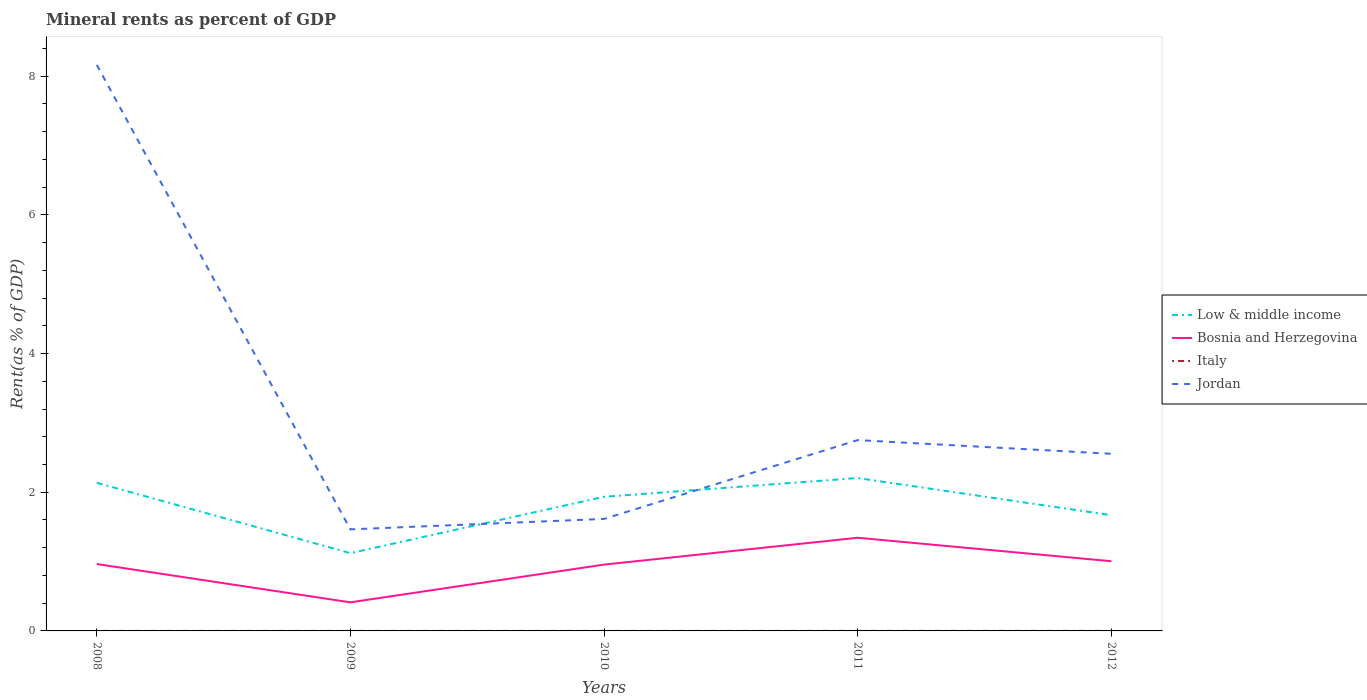How many different coloured lines are there?
Ensure brevity in your answer.  4. Across all years, what is the maximum mineral rent in Bosnia and Herzegovina?
Offer a terse response. 0.41. In which year was the mineral rent in Jordan maximum?
Your answer should be compact. 2009. What is the total mineral rent in Bosnia and Herzegovina in the graph?
Offer a terse response. -0.59. What is the difference between the highest and the second highest mineral rent in Italy?
Your answer should be compact. 0. What is the difference between the highest and the lowest mineral rent in Jordan?
Ensure brevity in your answer.  1. Is the mineral rent in Jordan strictly greater than the mineral rent in Bosnia and Herzegovina over the years?
Your answer should be very brief. No. How many lines are there?
Provide a succinct answer. 4. What is the difference between two consecutive major ticks on the Y-axis?
Offer a terse response. 2. Does the graph contain any zero values?
Provide a succinct answer. No. Does the graph contain grids?
Make the answer very short. No. How many legend labels are there?
Offer a very short reply. 4. What is the title of the graph?
Your answer should be compact. Mineral rents as percent of GDP. What is the label or title of the X-axis?
Your answer should be compact. Years. What is the label or title of the Y-axis?
Your answer should be very brief. Rent(as % of GDP). What is the Rent(as % of GDP) of Low & middle income in 2008?
Give a very brief answer. 2.14. What is the Rent(as % of GDP) in Bosnia and Herzegovina in 2008?
Your answer should be very brief. 0.96. What is the Rent(as % of GDP) in Italy in 2008?
Provide a succinct answer. 0. What is the Rent(as % of GDP) in Jordan in 2008?
Make the answer very short. 8.16. What is the Rent(as % of GDP) in Low & middle income in 2009?
Offer a terse response. 1.12. What is the Rent(as % of GDP) in Bosnia and Herzegovina in 2009?
Provide a short and direct response. 0.41. What is the Rent(as % of GDP) of Italy in 2009?
Provide a succinct answer. 0. What is the Rent(as % of GDP) of Jordan in 2009?
Your response must be concise. 1.46. What is the Rent(as % of GDP) in Low & middle income in 2010?
Provide a short and direct response. 1.93. What is the Rent(as % of GDP) in Bosnia and Herzegovina in 2010?
Provide a short and direct response. 0.96. What is the Rent(as % of GDP) in Italy in 2010?
Make the answer very short. 0. What is the Rent(as % of GDP) in Jordan in 2010?
Your response must be concise. 1.62. What is the Rent(as % of GDP) of Low & middle income in 2011?
Provide a short and direct response. 2.21. What is the Rent(as % of GDP) of Bosnia and Herzegovina in 2011?
Provide a short and direct response. 1.34. What is the Rent(as % of GDP) in Italy in 2011?
Your answer should be compact. 0. What is the Rent(as % of GDP) of Jordan in 2011?
Provide a succinct answer. 2.75. What is the Rent(as % of GDP) in Low & middle income in 2012?
Your response must be concise. 1.67. What is the Rent(as % of GDP) in Bosnia and Herzegovina in 2012?
Your response must be concise. 1.01. What is the Rent(as % of GDP) in Italy in 2012?
Make the answer very short. 0. What is the Rent(as % of GDP) in Jordan in 2012?
Offer a very short reply. 2.55. Across all years, what is the maximum Rent(as % of GDP) of Low & middle income?
Your answer should be very brief. 2.21. Across all years, what is the maximum Rent(as % of GDP) of Bosnia and Herzegovina?
Offer a very short reply. 1.34. Across all years, what is the maximum Rent(as % of GDP) in Italy?
Provide a succinct answer. 0. Across all years, what is the maximum Rent(as % of GDP) in Jordan?
Your answer should be very brief. 8.16. Across all years, what is the minimum Rent(as % of GDP) of Low & middle income?
Keep it short and to the point. 1.12. Across all years, what is the minimum Rent(as % of GDP) of Bosnia and Herzegovina?
Your response must be concise. 0.41. Across all years, what is the minimum Rent(as % of GDP) in Italy?
Your answer should be compact. 0. Across all years, what is the minimum Rent(as % of GDP) of Jordan?
Keep it short and to the point. 1.46. What is the total Rent(as % of GDP) of Low & middle income in the graph?
Provide a short and direct response. 9.07. What is the total Rent(as % of GDP) in Bosnia and Herzegovina in the graph?
Make the answer very short. 4.68. What is the total Rent(as % of GDP) of Italy in the graph?
Provide a short and direct response. 0. What is the total Rent(as % of GDP) in Jordan in the graph?
Your response must be concise. 16.55. What is the difference between the Rent(as % of GDP) of Low & middle income in 2008 and that in 2009?
Offer a very short reply. 1.02. What is the difference between the Rent(as % of GDP) in Bosnia and Herzegovina in 2008 and that in 2009?
Ensure brevity in your answer.  0.55. What is the difference between the Rent(as % of GDP) of Italy in 2008 and that in 2009?
Give a very brief answer. -0. What is the difference between the Rent(as % of GDP) in Jordan in 2008 and that in 2009?
Offer a terse response. 6.7. What is the difference between the Rent(as % of GDP) in Low & middle income in 2008 and that in 2010?
Offer a very short reply. 0.2. What is the difference between the Rent(as % of GDP) in Bosnia and Herzegovina in 2008 and that in 2010?
Give a very brief answer. 0.01. What is the difference between the Rent(as % of GDP) in Italy in 2008 and that in 2010?
Ensure brevity in your answer.  -0. What is the difference between the Rent(as % of GDP) of Jordan in 2008 and that in 2010?
Provide a succinct answer. 6.55. What is the difference between the Rent(as % of GDP) in Low & middle income in 2008 and that in 2011?
Make the answer very short. -0.07. What is the difference between the Rent(as % of GDP) of Bosnia and Herzegovina in 2008 and that in 2011?
Make the answer very short. -0.38. What is the difference between the Rent(as % of GDP) in Italy in 2008 and that in 2011?
Give a very brief answer. -0. What is the difference between the Rent(as % of GDP) of Jordan in 2008 and that in 2011?
Offer a terse response. 5.41. What is the difference between the Rent(as % of GDP) of Low & middle income in 2008 and that in 2012?
Offer a very short reply. 0.47. What is the difference between the Rent(as % of GDP) in Bosnia and Herzegovina in 2008 and that in 2012?
Ensure brevity in your answer.  -0.04. What is the difference between the Rent(as % of GDP) in Italy in 2008 and that in 2012?
Offer a terse response. -0. What is the difference between the Rent(as % of GDP) of Jordan in 2008 and that in 2012?
Your answer should be compact. 5.61. What is the difference between the Rent(as % of GDP) of Low & middle income in 2009 and that in 2010?
Ensure brevity in your answer.  -0.81. What is the difference between the Rent(as % of GDP) in Bosnia and Herzegovina in 2009 and that in 2010?
Ensure brevity in your answer.  -0.54. What is the difference between the Rent(as % of GDP) in Italy in 2009 and that in 2010?
Give a very brief answer. -0. What is the difference between the Rent(as % of GDP) of Jordan in 2009 and that in 2010?
Your answer should be compact. -0.15. What is the difference between the Rent(as % of GDP) in Low & middle income in 2009 and that in 2011?
Ensure brevity in your answer.  -1.08. What is the difference between the Rent(as % of GDP) of Bosnia and Herzegovina in 2009 and that in 2011?
Give a very brief answer. -0.93. What is the difference between the Rent(as % of GDP) in Italy in 2009 and that in 2011?
Offer a very short reply. -0. What is the difference between the Rent(as % of GDP) in Jordan in 2009 and that in 2011?
Offer a very short reply. -1.29. What is the difference between the Rent(as % of GDP) in Low & middle income in 2009 and that in 2012?
Ensure brevity in your answer.  -0.55. What is the difference between the Rent(as % of GDP) of Bosnia and Herzegovina in 2009 and that in 2012?
Provide a succinct answer. -0.59. What is the difference between the Rent(as % of GDP) in Italy in 2009 and that in 2012?
Provide a short and direct response. -0. What is the difference between the Rent(as % of GDP) of Jordan in 2009 and that in 2012?
Keep it short and to the point. -1.09. What is the difference between the Rent(as % of GDP) of Low & middle income in 2010 and that in 2011?
Your response must be concise. -0.27. What is the difference between the Rent(as % of GDP) in Bosnia and Herzegovina in 2010 and that in 2011?
Offer a terse response. -0.39. What is the difference between the Rent(as % of GDP) of Italy in 2010 and that in 2011?
Provide a short and direct response. -0. What is the difference between the Rent(as % of GDP) in Jordan in 2010 and that in 2011?
Your response must be concise. -1.14. What is the difference between the Rent(as % of GDP) in Low & middle income in 2010 and that in 2012?
Make the answer very short. 0.27. What is the difference between the Rent(as % of GDP) in Bosnia and Herzegovina in 2010 and that in 2012?
Make the answer very short. -0.05. What is the difference between the Rent(as % of GDP) in Italy in 2010 and that in 2012?
Give a very brief answer. -0. What is the difference between the Rent(as % of GDP) of Jordan in 2010 and that in 2012?
Provide a succinct answer. -0.94. What is the difference between the Rent(as % of GDP) in Low & middle income in 2011 and that in 2012?
Keep it short and to the point. 0.54. What is the difference between the Rent(as % of GDP) in Bosnia and Herzegovina in 2011 and that in 2012?
Offer a terse response. 0.34. What is the difference between the Rent(as % of GDP) of Italy in 2011 and that in 2012?
Provide a short and direct response. -0. What is the difference between the Rent(as % of GDP) in Jordan in 2011 and that in 2012?
Your response must be concise. 0.2. What is the difference between the Rent(as % of GDP) of Low & middle income in 2008 and the Rent(as % of GDP) of Bosnia and Herzegovina in 2009?
Your response must be concise. 1.72. What is the difference between the Rent(as % of GDP) of Low & middle income in 2008 and the Rent(as % of GDP) of Italy in 2009?
Ensure brevity in your answer.  2.14. What is the difference between the Rent(as % of GDP) in Low & middle income in 2008 and the Rent(as % of GDP) in Jordan in 2009?
Your answer should be very brief. 0.67. What is the difference between the Rent(as % of GDP) of Bosnia and Herzegovina in 2008 and the Rent(as % of GDP) of Italy in 2009?
Keep it short and to the point. 0.96. What is the difference between the Rent(as % of GDP) in Italy in 2008 and the Rent(as % of GDP) in Jordan in 2009?
Give a very brief answer. -1.46. What is the difference between the Rent(as % of GDP) in Low & middle income in 2008 and the Rent(as % of GDP) in Bosnia and Herzegovina in 2010?
Your response must be concise. 1.18. What is the difference between the Rent(as % of GDP) in Low & middle income in 2008 and the Rent(as % of GDP) in Italy in 2010?
Offer a very short reply. 2.14. What is the difference between the Rent(as % of GDP) of Low & middle income in 2008 and the Rent(as % of GDP) of Jordan in 2010?
Provide a short and direct response. 0.52. What is the difference between the Rent(as % of GDP) in Bosnia and Herzegovina in 2008 and the Rent(as % of GDP) in Italy in 2010?
Ensure brevity in your answer.  0.96. What is the difference between the Rent(as % of GDP) of Bosnia and Herzegovina in 2008 and the Rent(as % of GDP) of Jordan in 2010?
Make the answer very short. -0.65. What is the difference between the Rent(as % of GDP) in Italy in 2008 and the Rent(as % of GDP) in Jordan in 2010?
Your answer should be very brief. -1.62. What is the difference between the Rent(as % of GDP) of Low & middle income in 2008 and the Rent(as % of GDP) of Bosnia and Herzegovina in 2011?
Give a very brief answer. 0.79. What is the difference between the Rent(as % of GDP) of Low & middle income in 2008 and the Rent(as % of GDP) of Italy in 2011?
Provide a succinct answer. 2.14. What is the difference between the Rent(as % of GDP) of Low & middle income in 2008 and the Rent(as % of GDP) of Jordan in 2011?
Offer a very short reply. -0.62. What is the difference between the Rent(as % of GDP) of Bosnia and Herzegovina in 2008 and the Rent(as % of GDP) of Italy in 2011?
Your answer should be compact. 0.96. What is the difference between the Rent(as % of GDP) of Bosnia and Herzegovina in 2008 and the Rent(as % of GDP) of Jordan in 2011?
Your answer should be very brief. -1.79. What is the difference between the Rent(as % of GDP) in Italy in 2008 and the Rent(as % of GDP) in Jordan in 2011?
Make the answer very short. -2.75. What is the difference between the Rent(as % of GDP) of Low & middle income in 2008 and the Rent(as % of GDP) of Bosnia and Herzegovina in 2012?
Provide a succinct answer. 1.13. What is the difference between the Rent(as % of GDP) in Low & middle income in 2008 and the Rent(as % of GDP) in Italy in 2012?
Your answer should be compact. 2.14. What is the difference between the Rent(as % of GDP) of Low & middle income in 2008 and the Rent(as % of GDP) of Jordan in 2012?
Your response must be concise. -0.42. What is the difference between the Rent(as % of GDP) of Bosnia and Herzegovina in 2008 and the Rent(as % of GDP) of Italy in 2012?
Keep it short and to the point. 0.96. What is the difference between the Rent(as % of GDP) in Bosnia and Herzegovina in 2008 and the Rent(as % of GDP) in Jordan in 2012?
Offer a very short reply. -1.59. What is the difference between the Rent(as % of GDP) in Italy in 2008 and the Rent(as % of GDP) in Jordan in 2012?
Offer a very short reply. -2.55. What is the difference between the Rent(as % of GDP) in Low & middle income in 2009 and the Rent(as % of GDP) in Bosnia and Herzegovina in 2010?
Provide a succinct answer. 0.17. What is the difference between the Rent(as % of GDP) of Low & middle income in 2009 and the Rent(as % of GDP) of Italy in 2010?
Give a very brief answer. 1.12. What is the difference between the Rent(as % of GDP) in Low & middle income in 2009 and the Rent(as % of GDP) in Jordan in 2010?
Provide a succinct answer. -0.49. What is the difference between the Rent(as % of GDP) of Bosnia and Herzegovina in 2009 and the Rent(as % of GDP) of Italy in 2010?
Your answer should be very brief. 0.41. What is the difference between the Rent(as % of GDP) in Bosnia and Herzegovina in 2009 and the Rent(as % of GDP) in Jordan in 2010?
Provide a short and direct response. -1.2. What is the difference between the Rent(as % of GDP) of Italy in 2009 and the Rent(as % of GDP) of Jordan in 2010?
Offer a terse response. -1.62. What is the difference between the Rent(as % of GDP) of Low & middle income in 2009 and the Rent(as % of GDP) of Bosnia and Herzegovina in 2011?
Keep it short and to the point. -0.22. What is the difference between the Rent(as % of GDP) of Low & middle income in 2009 and the Rent(as % of GDP) of Italy in 2011?
Ensure brevity in your answer.  1.12. What is the difference between the Rent(as % of GDP) of Low & middle income in 2009 and the Rent(as % of GDP) of Jordan in 2011?
Ensure brevity in your answer.  -1.63. What is the difference between the Rent(as % of GDP) in Bosnia and Herzegovina in 2009 and the Rent(as % of GDP) in Italy in 2011?
Your response must be concise. 0.41. What is the difference between the Rent(as % of GDP) of Bosnia and Herzegovina in 2009 and the Rent(as % of GDP) of Jordan in 2011?
Your answer should be very brief. -2.34. What is the difference between the Rent(as % of GDP) in Italy in 2009 and the Rent(as % of GDP) in Jordan in 2011?
Make the answer very short. -2.75. What is the difference between the Rent(as % of GDP) of Low & middle income in 2009 and the Rent(as % of GDP) of Bosnia and Herzegovina in 2012?
Give a very brief answer. 0.12. What is the difference between the Rent(as % of GDP) in Low & middle income in 2009 and the Rent(as % of GDP) in Italy in 2012?
Keep it short and to the point. 1.12. What is the difference between the Rent(as % of GDP) in Low & middle income in 2009 and the Rent(as % of GDP) in Jordan in 2012?
Make the answer very short. -1.43. What is the difference between the Rent(as % of GDP) in Bosnia and Herzegovina in 2009 and the Rent(as % of GDP) in Italy in 2012?
Keep it short and to the point. 0.41. What is the difference between the Rent(as % of GDP) in Bosnia and Herzegovina in 2009 and the Rent(as % of GDP) in Jordan in 2012?
Ensure brevity in your answer.  -2.14. What is the difference between the Rent(as % of GDP) in Italy in 2009 and the Rent(as % of GDP) in Jordan in 2012?
Provide a short and direct response. -2.55. What is the difference between the Rent(as % of GDP) of Low & middle income in 2010 and the Rent(as % of GDP) of Bosnia and Herzegovina in 2011?
Offer a terse response. 0.59. What is the difference between the Rent(as % of GDP) of Low & middle income in 2010 and the Rent(as % of GDP) of Italy in 2011?
Your answer should be compact. 1.93. What is the difference between the Rent(as % of GDP) in Low & middle income in 2010 and the Rent(as % of GDP) in Jordan in 2011?
Offer a very short reply. -0.82. What is the difference between the Rent(as % of GDP) in Bosnia and Herzegovina in 2010 and the Rent(as % of GDP) in Italy in 2011?
Your response must be concise. 0.96. What is the difference between the Rent(as % of GDP) of Bosnia and Herzegovina in 2010 and the Rent(as % of GDP) of Jordan in 2011?
Give a very brief answer. -1.8. What is the difference between the Rent(as % of GDP) in Italy in 2010 and the Rent(as % of GDP) in Jordan in 2011?
Provide a short and direct response. -2.75. What is the difference between the Rent(as % of GDP) in Low & middle income in 2010 and the Rent(as % of GDP) in Bosnia and Herzegovina in 2012?
Keep it short and to the point. 0.93. What is the difference between the Rent(as % of GDP) in Low & middle income in 2010 and the Rent(as % of GDP) in Italy in 2012?
Your answer should be very brief. 1.93. What is the difference between the Rent(as % of GDP) of Low & middle income in 2010 and the Rent(as % of GDP) of Jordan in 2012?
Keep it short and to the point. -0.62. What is the difference between the Rent(as % of GDP) in Bosnia and Herzegovina in 2010 and the Rent(as % of GDP) in Italy in 2012?
Your answer should be compact. 0.96. What is the difference between the Rent(as % of GDP) in Bosnia and Herzegovina in 2010 and the Rent(as % of GDP) in Jordan in 2012?
Give a very brief answer. -1.6. What is the difference between the Rent(as % of GDP) of Italy in 2010 and the Rent(as % of GDP) of Jordan in 2012?
Keep it short and to the point. -2.55. What is the difference between the Rent(as % of GDP) in Low & middle income in 2011 and the Rent(as % of GDP) in Bosnia and Herzegovina in 2012?
Make the answer very short. 1.2. What is the difference between the Rent(as % of GDP) of Low & middle income in 2011 and the Rent(as % of GDP) of Italy in 2012?
Provide a short and direct response. 2.2. What is the difference between the Rent(as % of GDP) in Low & middle income in 2011 and the Rent(as % of GDP) in Jordan in 2012?
Provide a short and direct response. -0.35. What is the difference between the Rent(as % of GDP) of Bosnia and Herzegovina in 2011 and the Rent(as % of GDP) of Italy in 2012?
Offer a terse response. 1.34. What is the difference between the Rent(as % of GDP) in Bosnia and Herzegovina in 2011 and the Rent(as % of GDP) in Jordan in 2012?
Your response must be concise. -1.21. What is the difference between the Rent(as % of GDP) of Italy in 2011 and the Rent(as % of GDP) of Jordan in 2012?
Give a very brief answer. -2.55. What is the average Rent(as % of GDP) of Low & middle income per year?
Give a very brief answer. 1.81. What is the average Rent(as % of GDP) of Bosnia and Herzegovina per year?
Ensure brevity in your answer.  0.94. What is the average Rent(as % of GDP) in Italy per year?
Offer a terse response. 0. What is the average Rent(as % of GDP) of Jordan per year?
Offer a terse response. 3.31. In the year 2008, what is the difference between the Rent(as % of GDP) of Low & middle income and Rent(as % of GDP) of Bosnia and Herzegovina?
Offer a very short reply. 1.17. In the year 2008, what is the difference between the Rent(as % of GDP) of Low & middle income and Rent(as % of GDP) of Italy?
Your answer should be compact. 2.14. In the year 2008, what is the difference between the Rent(as % of GDP) of Low & middle income and Rent(as % of GDP) of Jordan?
Ensure brevity in your answer.  -6.03. In the year 2008, what is the difference between the Rent(as % of GDP) in Bosnia and Herzegovina and Rent(as % of GDP) in Italy?
Provide a succinct answer. 0.96. In the year 2008, what is the difference between the Rent(as % of GDP) of Bosnia and Herzegovina and Rent(as % of GDP) of Jordan?
Make the answer very short. -7.2. In the year 2008, what is the difference between the Rent(as % of GDP) in Italy and Rent(as % of GDP) in Jordan?
Your answer should be very brief. -8.16. In the year 2009, what is the difference between the Rent(as % of GDP) in Low & middle income and Rent(as % of GDP) in Bosnia and Herzegovina?
Your response must be concise. 0.71. In the year 2009, what is the difference between the Rent(as % of GDP) of Low & middle income and Rent(as % of GDP) of Italy?
Ensure brevity in your answer.  1.12. In the year 2009, what is the difference between the Rent(as % of GDP) of Low & middle income and Rent(as % of GDP) of Jordan?
Offer a terse response. -0.34. In the year 2009, what is the difference between the Rent(as % of GDP) in Bosnia and Herzegovina and Rent(as % of GDP) in Italy?
Make the answer very short. 0.41. In the year 2009, what is the difference between the Rent(as % of GDP) in Bosnia and Herzegovina and Rent(as % of GDP) in Jordan?
Your answer should be compact. -1.05. In the year 2009, what is the difference between the Rent(as % of GDP) of Italy and Rent(as % of GDP) of Jordan?
Your answer should be very brief. -1.46. In the year 2010, what is the difference between the Rent(as % of GDP) of Low & middle income and Rent(as % of GDP) of Bosnia and Herzegovina?
Keep it short and to the point. 0.98. In the year 2010, what is the difference between the Rent(as % of GDP) in Low & middle income and Rent(as % of GDP) in Italy?
Keep it short and to the point. 1.93. In the year 2010, what is the difference between the Rent(as % of GDP) in Low & middle income and Rent(as % of GDP) in Jordan?
Offer a very short reply. 0.32. In the year 2010, what is the difference between the Rent(as % of GDP) of Bosnia and Herzegovina and Rent(as % of GDP) of Italy?
Ensure brevity in your answer.  0.96. In the year 2010, what is the difference between the Rent(as % of GDP) in Bosnia and Herzegovina and Rent(as % of GDP) in Jordan?
Provide a succinct answer. -0.66. In the year 2010, what is the difference between the Rent(as % of GDP) in Italy and Rent(as % of GDP) in Jordan?
Ensure brevity in your answer.  -1.61. In the year 2011, what is the difference between the Rent(as % of GDP) in Low & middle income and Rent(as % of GDP) in Bosnia and Herzegovina?
Provide a short and direct response. 0.86. In the year 2011, what is the difference between the Rent(as % of GDP) of Low & middle income and Rent(as % of GDP) of Italy?
Offer a very short reply. 2.2. In the year 2011, what is the difference between the Rent(as % of GDP) of Low & middle income and Rent(as % of GDP) of Jordan?
Offer a terse response. -0.55. In the year 2011, what is the difference between the Rent(as % of GDP) of Bosnia and Herzegovina and Rent(as % of GDP) of Italy?
Your answer should be compact. 1.34. In the year 2011, what is the difference between the Rent(as % of GDP) of Bosnia and Herzegovina and Rent(as % of GDP) of Jordan?
Ensure brevity in your answer.  -1.41. In the year 2011, what is the difference between the Rent(as % of GDP) of Italy and Rent(as % of GDP) of Jordan?
Your answer should be very brief. -2.75. In the year 2012, what is the difference between the Rent(as % of GDP) in Low & middle income and Rent(as % of GDP) in Bosnia and Herzegovina?
Offer a terse response. 0.66. In the year 2012, what is the difference between the Rent(as % of GDP) of Low & middle income and Rent(as % of GDP) of Italy?
Make the answer very short. 1.67. In the year 2012, what is the difference between the Rent(as % of GDP) of Low & middle income and Rent(as % of GDP) of Jordan?
Offer a very short reply. -0.89. In the year 2012, what is the difference between the Rent(as % of GDP) of Bosnia and Herzegovina and Rent(as % of GDP) of Jordan?
Your answer should be compact. -1.55. In the year 2012, what is the difference between the Rent(as % of GDP) in Italy and Rent(as % of GDP) in Jordan?
Your response must be concise. -2.55. What is the ratio of the Rent(as % of GDP) of Low & middle income in 2008 to that in 2009?
Your response must be concise. 1.91. What is the ratio of the Rent(as % of GDP) of Bosnia and Herzegovina in 2008 to that in 2009?
Your answer should be compact. 2.34. What is the ratio of the Rent(as % of GDP) in Italy in 2008 to that in 2009?
Your answer should be very brief. 0.78. What is the ratio of the Rent(as % of GDP) in Jordan in 2008 to that in 2009?
Make the answer very short. 5.57. What is the ratio of the Rent(as % of GDP) of Low & middle income in 2008 to that in 2010?
Provide a succinct answer. 1.1. What is the ratio of the Rent(as % of GDP) of Bosnia and Herzegovina in 2008 to that in 2010?
Give a very brief answer. 1.01. What is the ratio of the Rent(as % of GDP) in Italy in 2008 to that in 2010?
Give a very brief answer. 0.55. What is the ratio of the Rent(as % of GDP) in Jordan in 2008 to that in 2010?
Your response must be concise. 5.05. What is the ratio of the Rent(as % of GDP) of Low & middle income in 2008 to that in 2011?
Give a very brief answer. 0.97. What is the ratio of the Rent(as % of GDP) in Bosnia and Herzegovina in 2008 to that in 2011?
Give a very brief answer. 0.72. What is the ratio of the Rent(as % of GDP) in Italy in 2008 to that in 2011?
Offer a very short reply. 0.44. What is the ratio of the Rent(as % of GDP) of Jordan in 2008 to that in 2011?
Your response must be concise. 2.97. What is the ratio of the Rent(as % of GDP) of Low & middle income in 2008 to that in 2012?
Provide a short and direct response. 1.28. What is the ratio of the Rent(as % of GDP) of Bosnia and Herzegovina in 2008 to that in 2012?
Your answer should be compact. 0.96. What is the ratio of the Rent(as % of GDP) of Italy in 2008 to that in 2012?
Your response must be concise. 0.37. What is the ratio of the Rent(as % of GDP) of Jordan in 2008 to that in 2012?
Ensure brevity in your answer.  3.2. What is the ratio of the Rent(as % of GDP) of Low & middle income in 2009 to that in 2010?
Give a very brief answer. 0.58. What is the ratio of the Rent(as % of GDP) in Bosnia and Herzegovina in 2009 to that in 2010?
Keep it short and to the point. 0.43. What is the ratio of the Rent(as % of GDP) of Italy in 2009 to that in 2010?
Keep it short and to the point. 0.71. What is the ratio of the Rent(as % of GDP) in Jordan in 2009 to that in 2010?
Ensure brevity in your answer.  0.91. What is the ratio of the Rent(as % of GDP) of Low & middle income in 2009 to that in 2011?
Offer a very short reply. 0.51. What is the ratio of the Rent(as % of GDP) of Bosnia and Herzegovina in 2009 to that in 2011?
Offer a terse response. 0.31. What is the ratio of the Rent(as % of GDP) of Italy in 2009 to that in 2011?
Provide a succinct answer. 0.57. What is the ratio of the Rent(as % of GDP) in Jordan in 2009 to that in 2011?
Give a very brief answer. 0.53. What is the ratio of the Rent(as % of GDP) in Low & middle income in 2009 to that in 2012?
Your response must be concise. 0.67. What is the ratio of the Rent(as % of GDP) in Bosnia and Herzegovina in 2009 to that in 2012?
Keep it short and to the point. 0.41. What is the ratio of the Rent(as % of GDP) of Italy in 2009 to that in 2012?
Provide a short and direct response. 0.48. What is the ratio of the Rent(as % of GDP) in Jordan in 2009 to that in 2012?
Offer a terse response. 0.57. What is the ratio of the Rent(as % of GDP) of Low & middle income in 2010 to that in 2011?
Your response must be concise. 0.88. What is the ratio of the Rent(as % of GDP) of Bosnia and Herzegovina in 2010 to that in 2011?
Give a very brief answer. 0.71. What is the ratio of the Rent(as % of GDP) of Italy in 2010 to that in 2011?
Keep it short and to the point. 0.8. What is the ratio of the Rent(as % of GDP) in Jordan in 2010 to that in 2011?
Your answer should be compact. 0.59. What is the ratio of the Rent(as % of GDP) in Low & middle income in 2010 to that in 2012?
Ensure brevity in your answer.  1.16. What is the ratio of the Rent(as % of GDP) of Bosnia and Herzegovina in 2010 to that in 2012?
Your response must be concise. 0.95. What is the ratio of the Rent(as % of GDP) of Italy in 2010 to that in 2012?
Give a very brief answer. 0.68. What is the ratio of the Rent(as % of GDP) of Jordan in 2010 to that in 2012?
Make the answer very short. 0.63. What is the ratio of the Rent(as % of GDP) of Low & middle income in 2011 to that in 2012?
Ensure brevity in your answer.  1.32. What is the ratio of the Rent(as % of GDP) of Bosnia and Herzegovina in 2011 to that in 2012?
Your answer should be compact. 1.34. What is the ratio of the Rent(as % of GDP) in Italy in 2011 to that in 2012?
Your answer should be compact. 0.85. What is the ratio of the Rent(as % of GDP) of Jordan in 2011 to that in 2012?
Your answer should be compact. 1.08. What is the difference between the highest and the second highest Rent(as % of GDP) in Low & middle income?
Offer a terse response. 0.07. What is the difference between the highest and the second highest Rent(as % of GDP) of Bosnia and Herzegovina?
Your answer should be compact. 0.34. What is the difference between the highest and the second highest Rent(as % of GDP) of Jordan?
Your answer should be very brief. 5.41. What is the difference between the highest and the lowest Rent(as % of GDP) in Low & middle income?
Your answer should be very brief. 1.08. What is the difference between the highest and the lowest Rent(as % of GDP) of Bosnia and Herzegovina?
Make the answer very short. 0.93. What is the difference between the highest and the lowest Rent(as % of GDP) in Italy?
Offer a very short reply. 0. What is the difference between the highest and the lowest Rent(as % of GDP) of Jordan?
Ensure brevity in your answer.  6.7. 